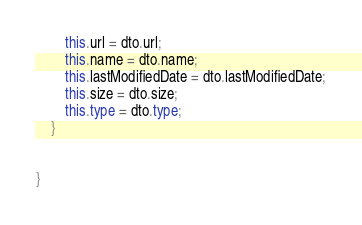<code> <loc_0><loc_0><loc_500><loc_500><_TypeScript_>        this.url = dto.url;
        this.name = dto.name;
        this.lastModifiedDate = dto.lastModifiedDate;
        this.size = dto.size;
        this.type = dto.type;
    }


}</code> 